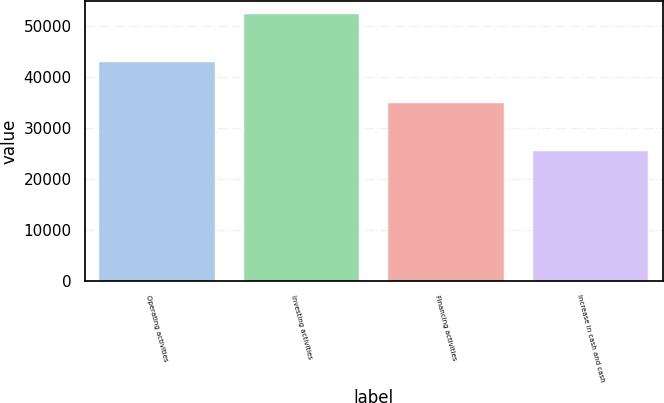Convert chart to OTSL. <chart><loc_0><loc_0><loc_500><loc_500><bar_chart><fcel>Operating activities<fcel>Investing activities<fcel>Financing activities<fcel>Increase in cash and cash<nl><fcel>42972<fcel>52324<fcel>34922<fcel>25570<nl></chart> 